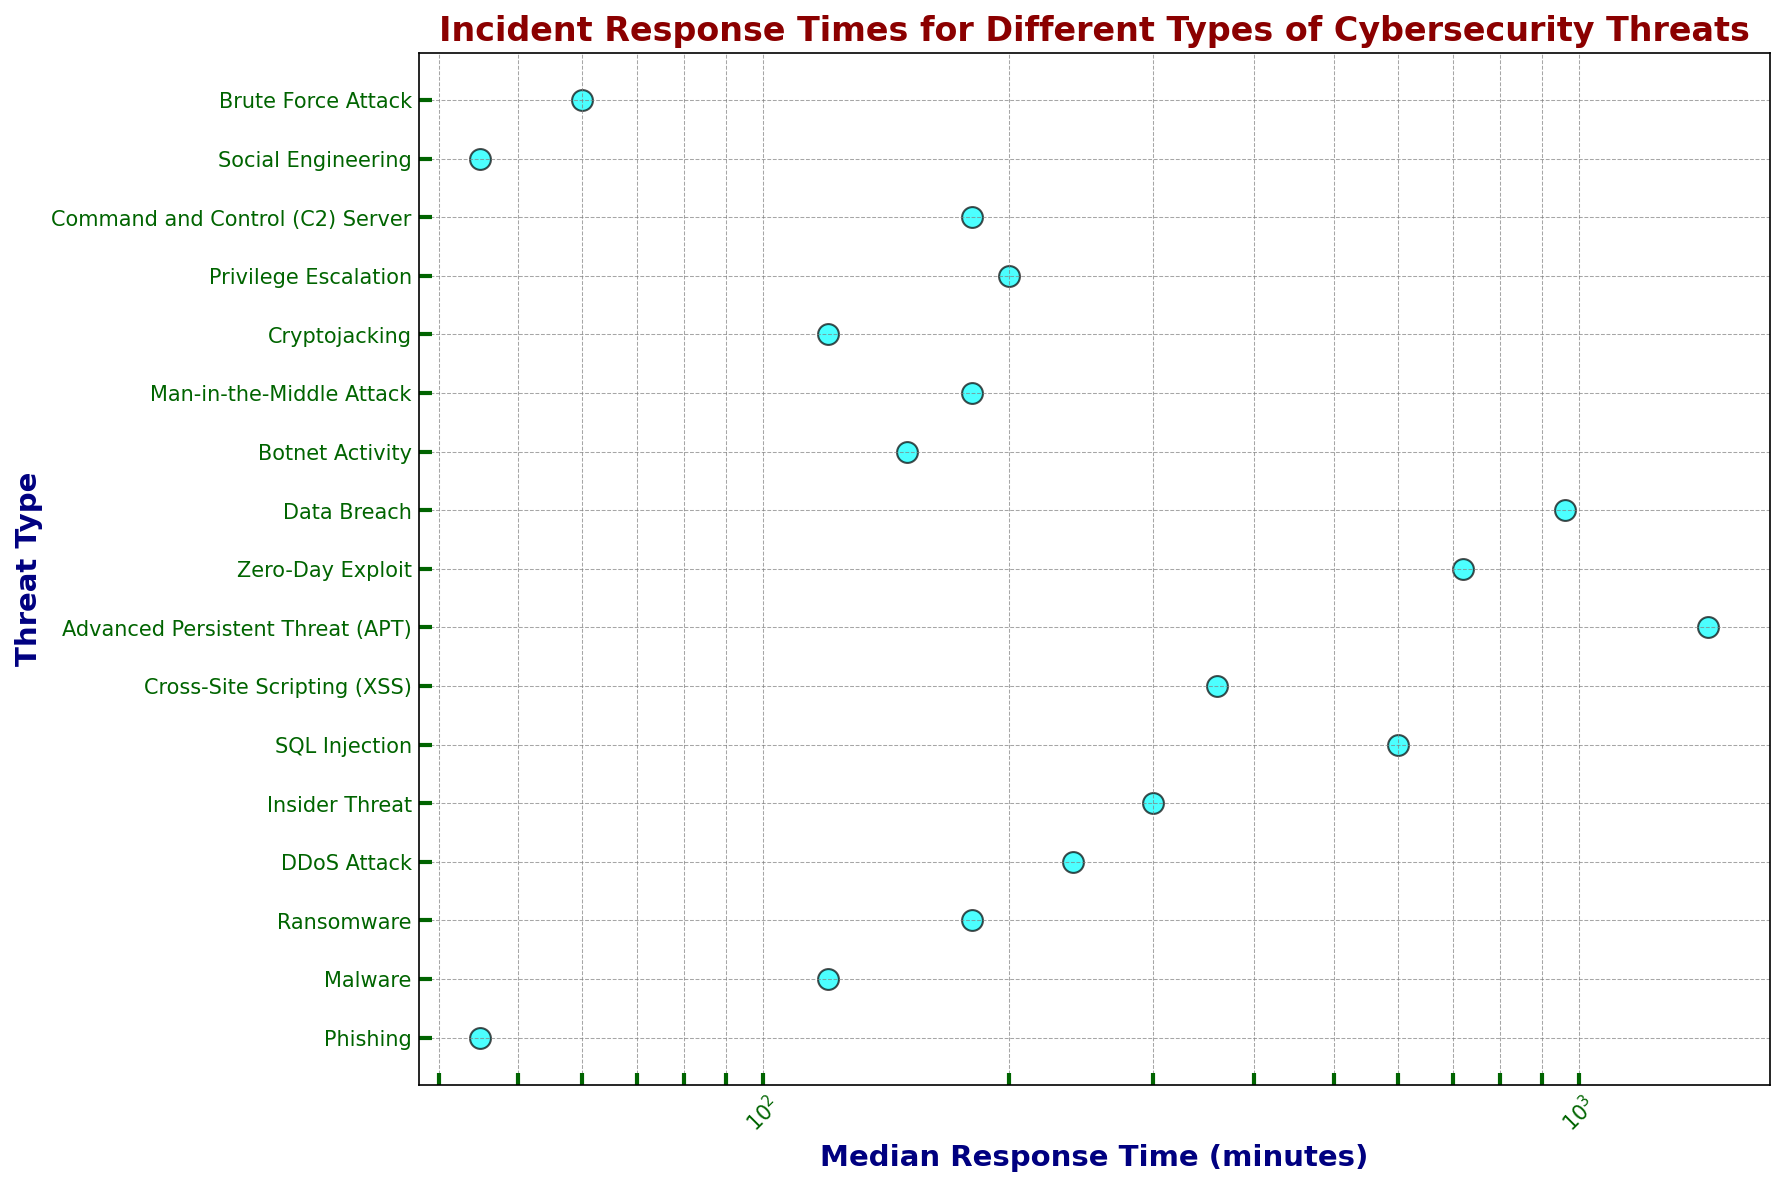Which threat type has the shortest median response time? Look for the threat type with the smallest median response time in minutes on the x-axis. The smallest value is 45 minutes, which corresponds to Phishing and Social Engineering.
Answer: Phishing and Social Engineering Which threat type has the longest median response time? Find the threat type with the largest value on the x-axis in minutes. The largest value shown is 1440 minutes, corresponding to Advanced Persistent Threat (APT).
Answer: Advanced Persistent Threat (APT) How do the response times for Malware and Cryptojacking compare? Compare the x-axis values for Malware and Cryptojacking. Both have median response times of 120 minutes.
Answer: Equal What is the difference in median response times between Insider Threat and Zero-Day Exploit? Subtract the median response time of Zero-Day Exploit (720 minutes) from that of Insider Threat (300 minutes).
Answer: 420 minutes Which has a greater median response time: DDoS Attack or SQL Injection? Compare the x-axis values for DDoS Attack and SQL Injection. 240 minutes for DDoS Attack is less than 600 minutes for SQL Injection.
Answer: SQL Injection On average, what is the median response time for Phishing, Malware, and Ransomware? Calculate the average of the median response times for Phishing (45), Malware (120), and Ransomware (180). The sum is 345, and the average is 345/3.
Answer: 115 minutes Is the median response time for Botnet Activity greater than that for Brute Force Attack? Compare the x-axis values for Botnet Activity and Brute Force Attack. 150 minutes is greater than 60 minutes.
Answer: Yes Which threats have a median response time of 180 minutes? Look for the threat types with x-axis values of 180 minutes. These are Ransomware, Man-in-the-Middle Attack, and Command and Control (C2) Server.
Answer: Ransomware, Man-in-the-Middle Attack, Command and Control (C2) Server What is the ratio of the median response time for Data Breach to that for DDoS Attack? Divide the median response time for Data Breach (960) by that for DDoS Attack (240). The ratio is 960/240 = 4.
Answer: 4 By how much does the median response time for Brute Force Attack differ from that of Privilege Escalation? Subtract the median response time of Brute Force Attack (60 minutes) from that of Privilege Escalation (200 minutes).
Answer: 140 minutes 